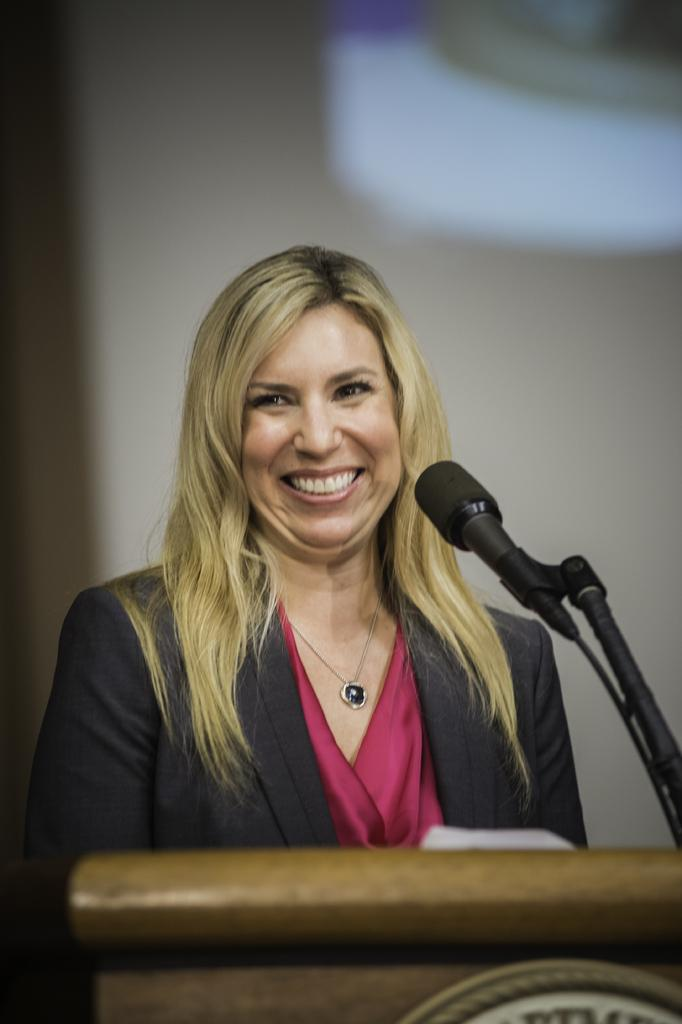Who is the main subject in the image? There is a lady in the center of the image. What is in front of the lady? There is a desk and a microphone (mic) in front of the lady. What type of stage is the lady performing on in the image? There is no stage present in the image; it only features a lady, a desk, and a microphone. 